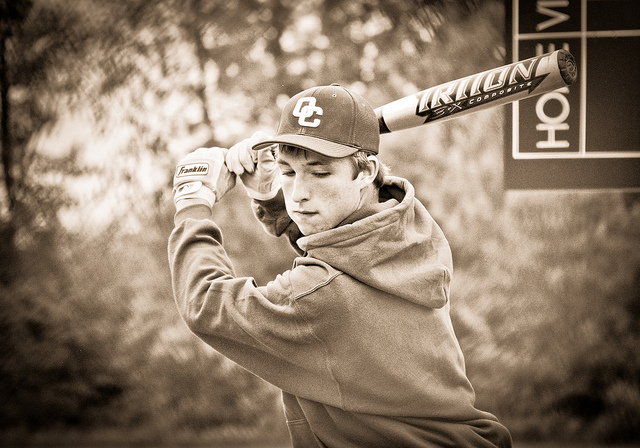Read and extract the text from this image. VI HO TRITON FRANKLIN 